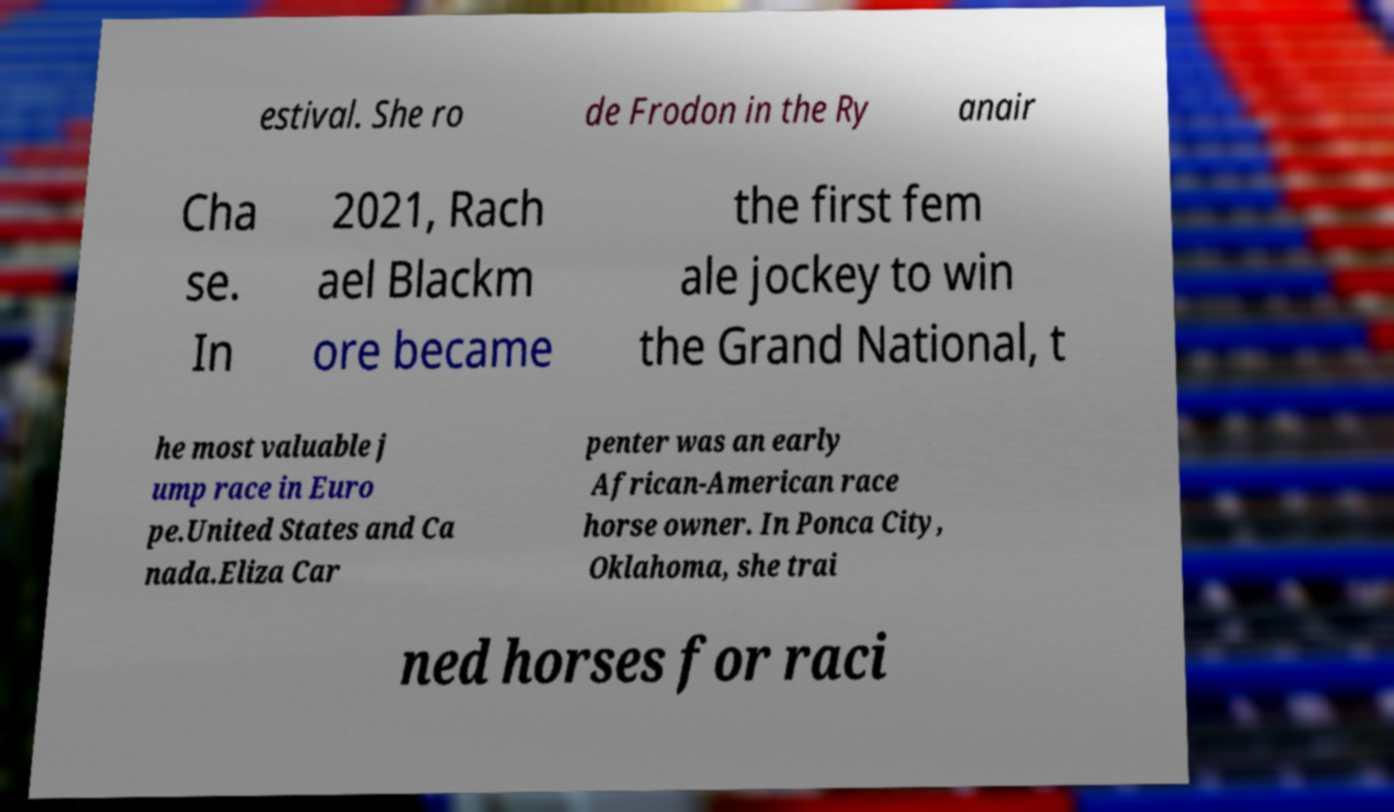Could you assist in decoding the text presented in this image and type it out clearly? estival. She ro de Frodon in the Ry anair Cha se. In 2021, Rach ael Blackm ore became the first fem ale jockey to win the Grand National, t he most valuable j ump race in Euro pe.United States and Ca nada.Eliza Car penter was an early African-American race horse owner. In Ponca City, Oklahoma, she trai ned horses for raci 